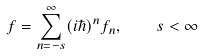<formula> <loc_0><loc_0><loc_500><loc_500>f = \sum _ { n = - s } ^ { \infty } ( i \hbar { ) } ^ { n } f _ { n } , \quad s < \infty</formula> 